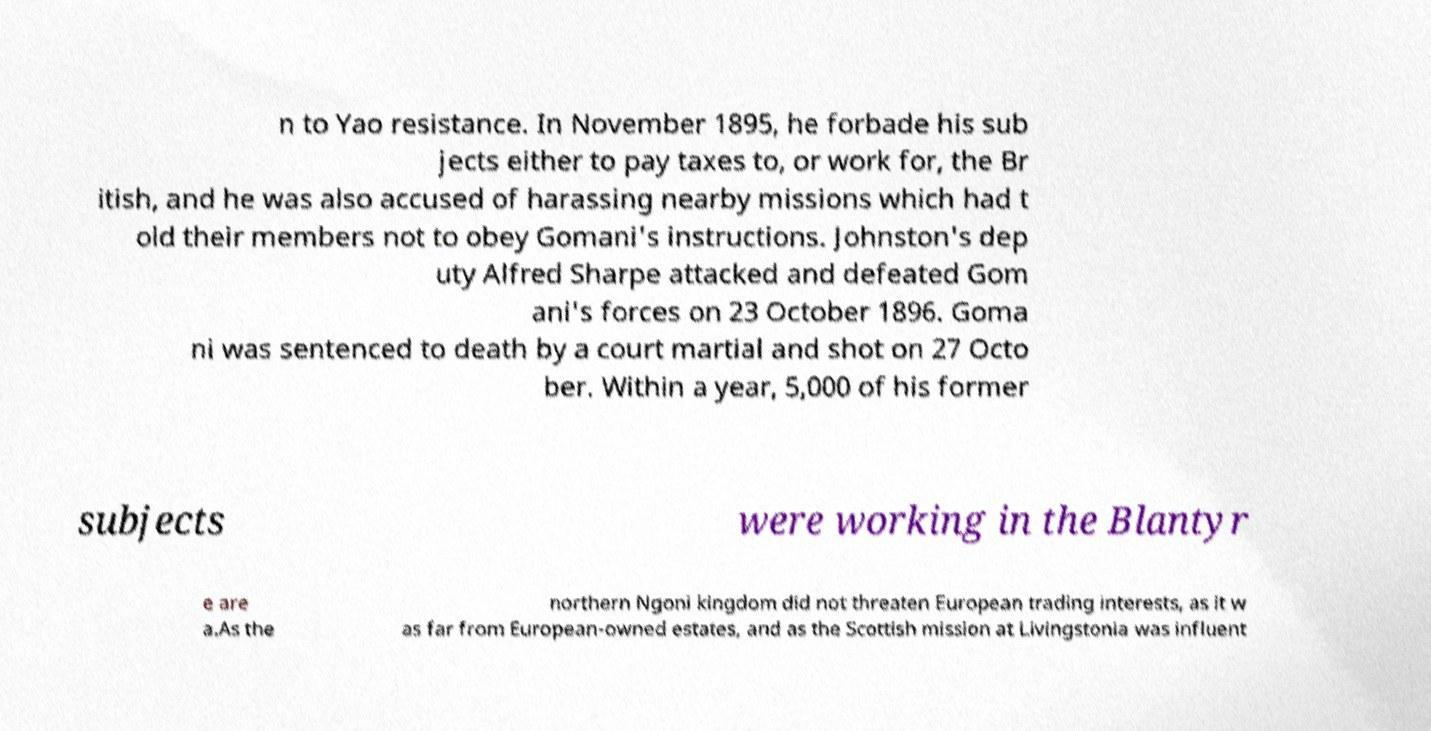Please read and relay the text visible in this image. What does it say? n to Yao resistance. In November 1895, he forbade his sub jects either to pay taxes to, or work for, the Br itish, and he was also accused of harassing nearby missions which had t old their members not to obey Gomani's instructions. Johnston's dep uty Alfred Sharpe attacked and defeated Gom ani's forces on 23 October 1896. Goma ni was sentenced to death by a court martial and shot on 27 Octo ber. Within a year, 5,000 of his former subjects were working in the Blantyr e are a.As the northern Ngoni kingdom did not threaten European trading interests, as it w as far from European-owned estates, and as the Scottish mission at Livingstonia was influent 